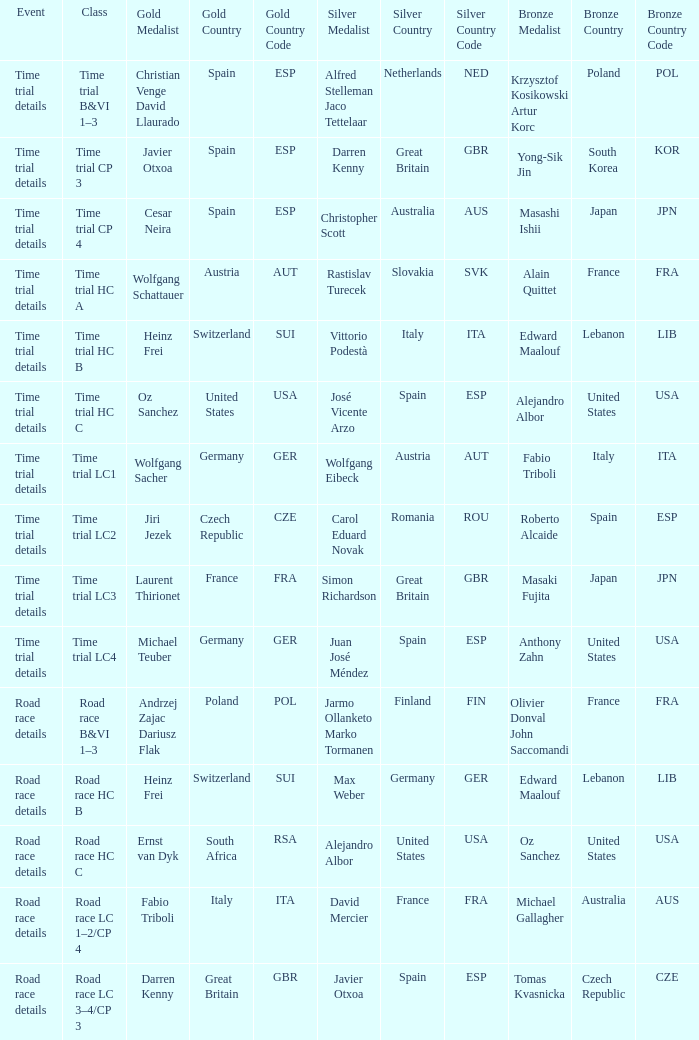What is the event when gold is darren kenny great britain (gbr)? Road race details. 